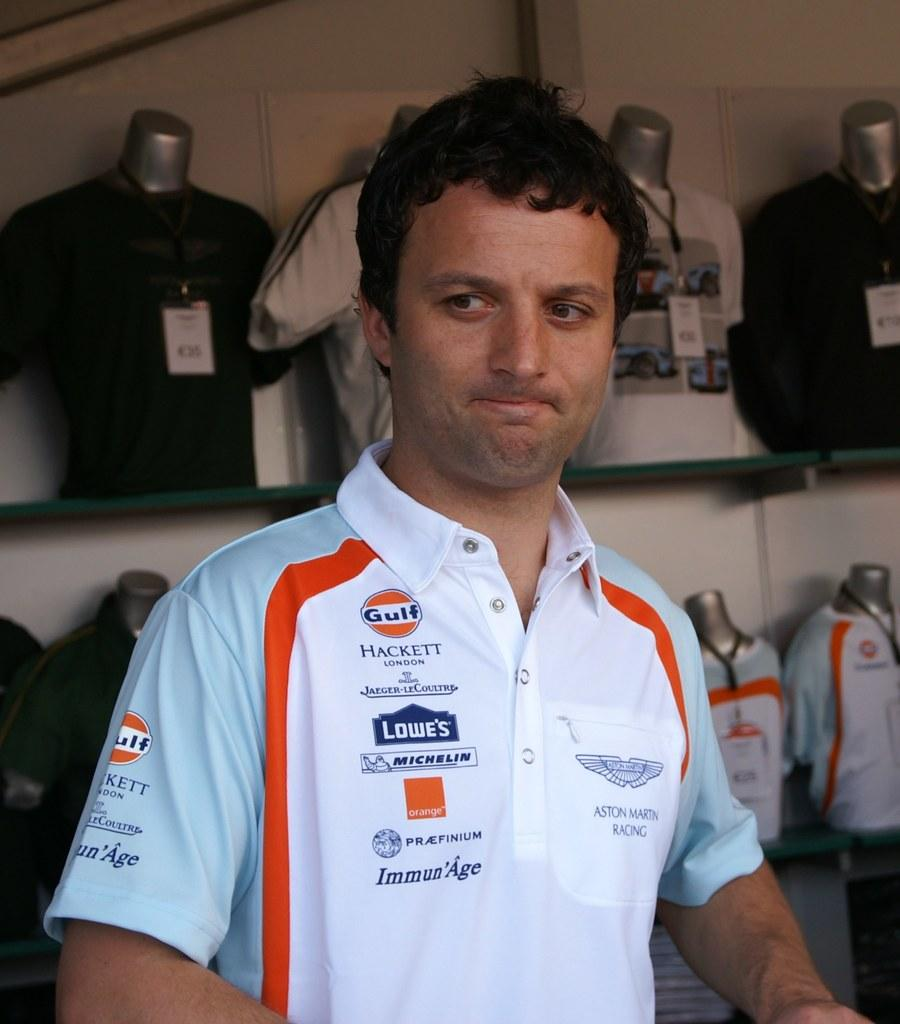Provide a one-sentence caption for the provided image. A man's pro racing shirt is covered with advertisements for Gulf, Lowe's and others. 